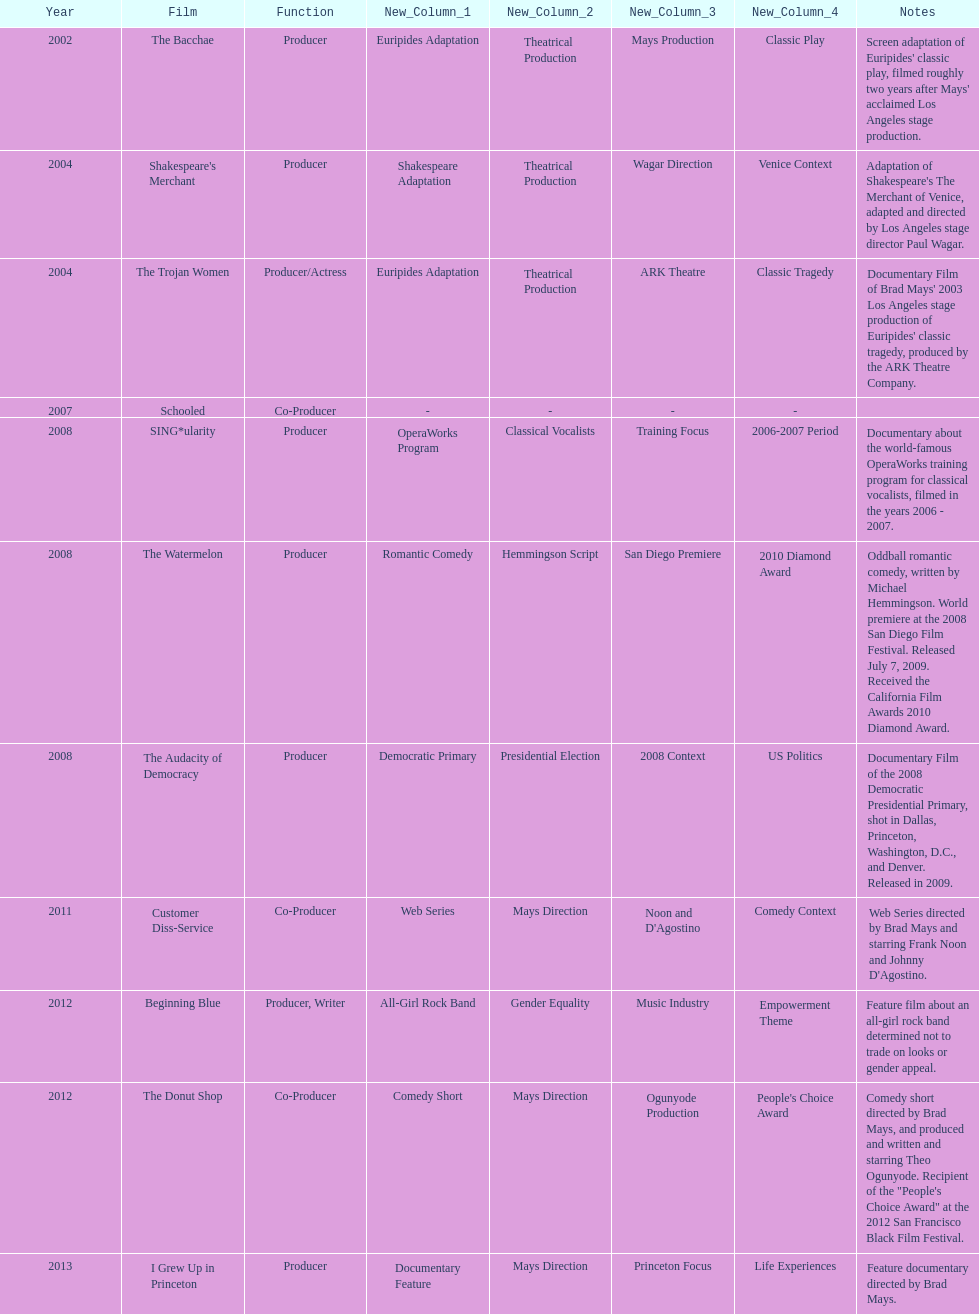How many years before was the film bacchae out before the watermelon? 6. 